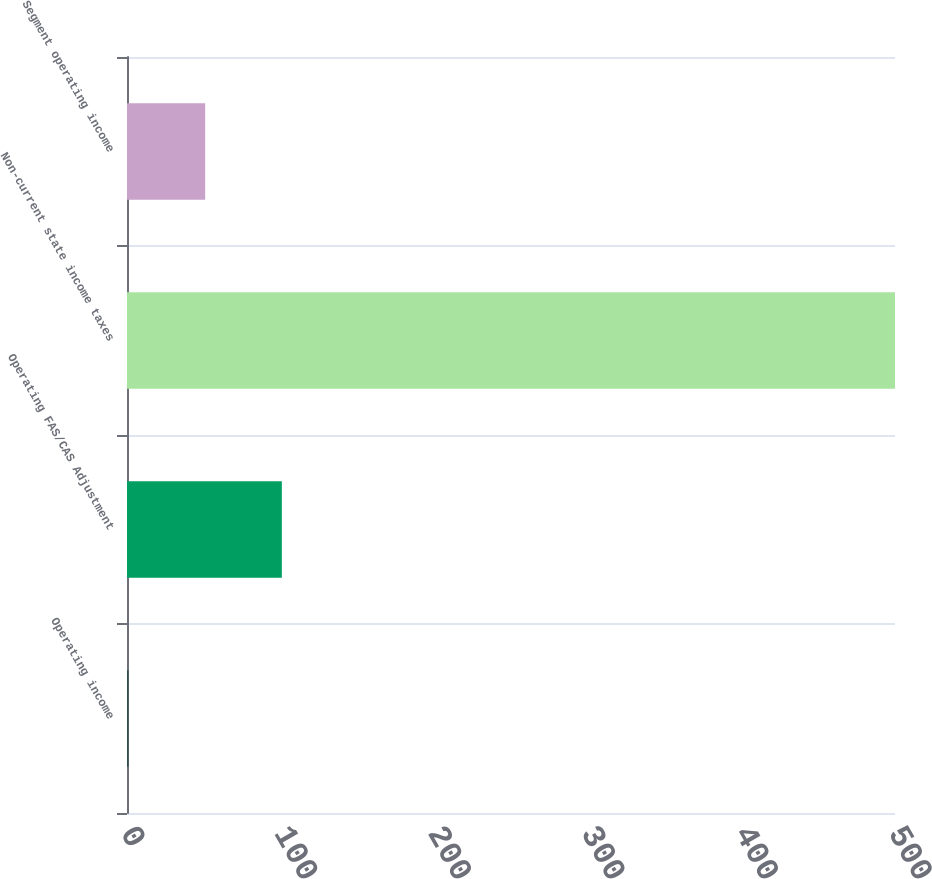Convert chart to OTSL. <chart><loc_0><loc_0><loc_500><loc_500><bar_chart><fcel>Operating income<fcel>Operating FAS/CAS Adjustment<fcel>Non-current state income taxes<fcel>Segment operating income<nl><fcel>1<fcel>100.8<fcel>500<fcel>50.9<nl></chart> 